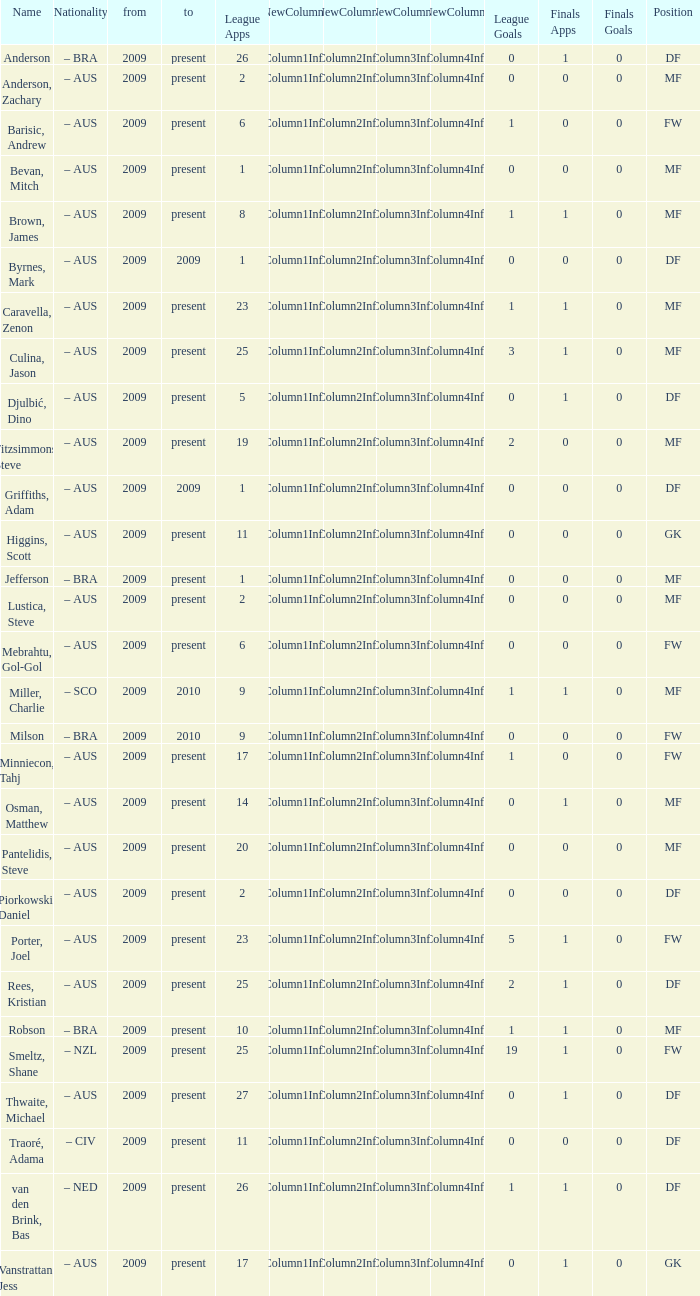Could you parse the entire table? {'header': ['Name', 'Nationality', 'from', 'to', 'League Apps', 'NewColumn1', 'NewColumn2', 'NewColumn3', 'NewColumn4', 'League Goals', 'Finals Apps', 'Finals Goals', 'Position'], 'rows': [['Anderson', '– BRA', '2009', 'present', '26', 'Column1Info', 'Column2Info', 'Column3Info', 'Column4Info', '0', '1', '0', 'DF'], ['Anderson, Zachary', '– AUS', '2009', 'present', '2', 'Column1Info', 'Column2Info', 'Column3Info', 'Column4Info', '0', '0', '0', 'MF'], ['Barisic, Andrew', '– AUS', '2009', 'present', '6', 'Column1Info', 'Column2Info', 'Column3Info', 'Column4Info', '1', '0', '0', 'FW'], ['Bevan, Mitch', '– AUS', '2009', 'present', '1', 'Column1Info', 'Column2Info', 'Column3Info', 'Column4Info', '0', '0', '0', 'MF'], ['Brown, James', '– AUS', '2009', 'present', '8', 'Column1Info', 'Column2Info', 'Column3Info', 'Column4Info', '1', '1', '0', 'MF'], ['Byrnes, Mark', '– AUS', '2009', '2009', '1', 'Column1Info', 'Column2Info', 'Column3Info', 'Column4Info', '0', '0', '0', 'DF'], ['Caravella, Zenon', '– AUS', '2009', 'present', '23', 'Column1Info', 'Column2Info', 'Column3Info', 'Column4Info', '1', '1', '0', 'MF'], ['Culina, Jason', '– AUS', '2009', 'present', '25', 'Column1Info', 'Column2Info', 'Column3Info', 'Column4Info', '3', '1', '0', 'MF'], ['Djulbić, Dino', '– AUS', '2009', 'present', '5', 'Column1Info', 'Column2Info', 'Column3Info', 'Column4Info', '0', '1', '0', 'DF'], ['Fitzsimmons, Steve', '– AUS', '2009', 'present', '19', 'Column1Info', 'Column2Info', 'Column3Info', 'Column4Info', '2', '0', '0', 'MF'], ['Griffiths, Adam', '– AUS', '2009', '2009', '1', 'Column1Info', 'Column2Info', 'Column3Info', 'Column4Info', '0', '0', '0', 'DF'], ['Higgins, Scott', '– AUS', '2009', 'present', '11', 'Column1Info', 'Column2Info', 'Column3Info', 'Column4Info', '0', '0', '0', 'GK'], ['Jefferson', '– BRA', '2009', 'present', '1', 'Column1Info', 'Column2Info', 'Column3Info', 'Column4Info', '0', '0', '0', 'MF'], ['Lustica, Steve', '– AUS', '2009', 'present', '2', 'Column1Info', 'Column2Info', 'Column3Info', 'Column4Info', '0', '0', '0', 'MF'], ['Mebrahtu, Gol-Gol', '– AUS', '2009', 'present', '6', 'Column1Info', 'Column2Info', 'Column3Info', 'Column4Info', '0', '0', '0', 'FW'], ['Miller, Charlie', '– SCO', '2009', '2010', '9', 'Column1Info', 'Column2Info', 'Column3Info', 'Column4Info', '1', '1', '0', 'MF'], ['Milson', '– BRA', '2009', '2010', '9', 'Column1Info', 'Column2Info', 'Column3Info', 'Column4Info', '0', '0', '0', 'FW'], ['Minniecon, Tahj', '– AUS', '2009', 'present', '17', 'Column1Info', 'Column2Info', 'Column3Info', 'Column4Info', '1', '0', '0', 'FW'], ['Osman, Matthew', '– AUS', '2009', 'present', '14', 'Column1Info', 'Column2Info', 'Column3Info', 'Column4Info', '0', '1', '0', 'MF'], ['Pantelidis, Steve', '– AUS', '2009', 'present', '20', 'Column1Info', 'Column2Info', 'Column3Info', 'Column4Info', '0', '0', '0', 'MF'], ['Piorkowski, Daniel', '– AUS', '2009', 'present', '2', 'Column1Info', 'Column2Info', 'Column3Info', 'Column4Info', '0', '0', '0', 'DF'], ['Porter, Joel', '– AUS', '2009', 'present', '23', 'Column1Info', 'Column2Info', 'Column3Info', 'Column4Info', '5', '1', '0', 'FW'], ['Rees, Kristian', '– AUS', '2009', 'present', '25', 'Column1Info', 'Column2Info', 'Column3Info', 'Column4Info', '2', '1', '0', 'DF'], ['Robson', '– BRA', '2009', 'present', '10', 'Column1Info', 'Column2Info', 'Column3Info', 'Column4Info', '1', '1', '0', 'MF'], ['Smeltz, Shane', '– NZL', '2009', 'present', '25', 'Column1Info', 'Column2Info', 'Column3Info', 'Column4Info', '19', '1', '0', 'FW'], ['Thwaite, Michael', '– AUS', '2009', 'present', '27', 'Column1Info', 'Column2Info', 'Column3Info', 'Column4Info', '0', '1', '0', 'DF'], ['Traoré, Adama', '– CIV', '2009', 'present', '11', 'Column1Info', 'Column2Info', 'Column3Info', 'Column4Info', '0', '0', '0', 'DF'], ['van den Brink, Bas', '– NED', '2009', 'present', '26', 'Column1Info', 'Column2Info', 'Column3Info', 'Column4Info', '1', '1', '0', 'DF'], ['Vanstrattan, Jess', '– AUS', '2009', 'present', '17', 'Column1Info', 'Column2Info', 'Column3Info', 'Column4Info', '0', '1', '0', 'GK']]} Name the to for 19 league apps Present. 